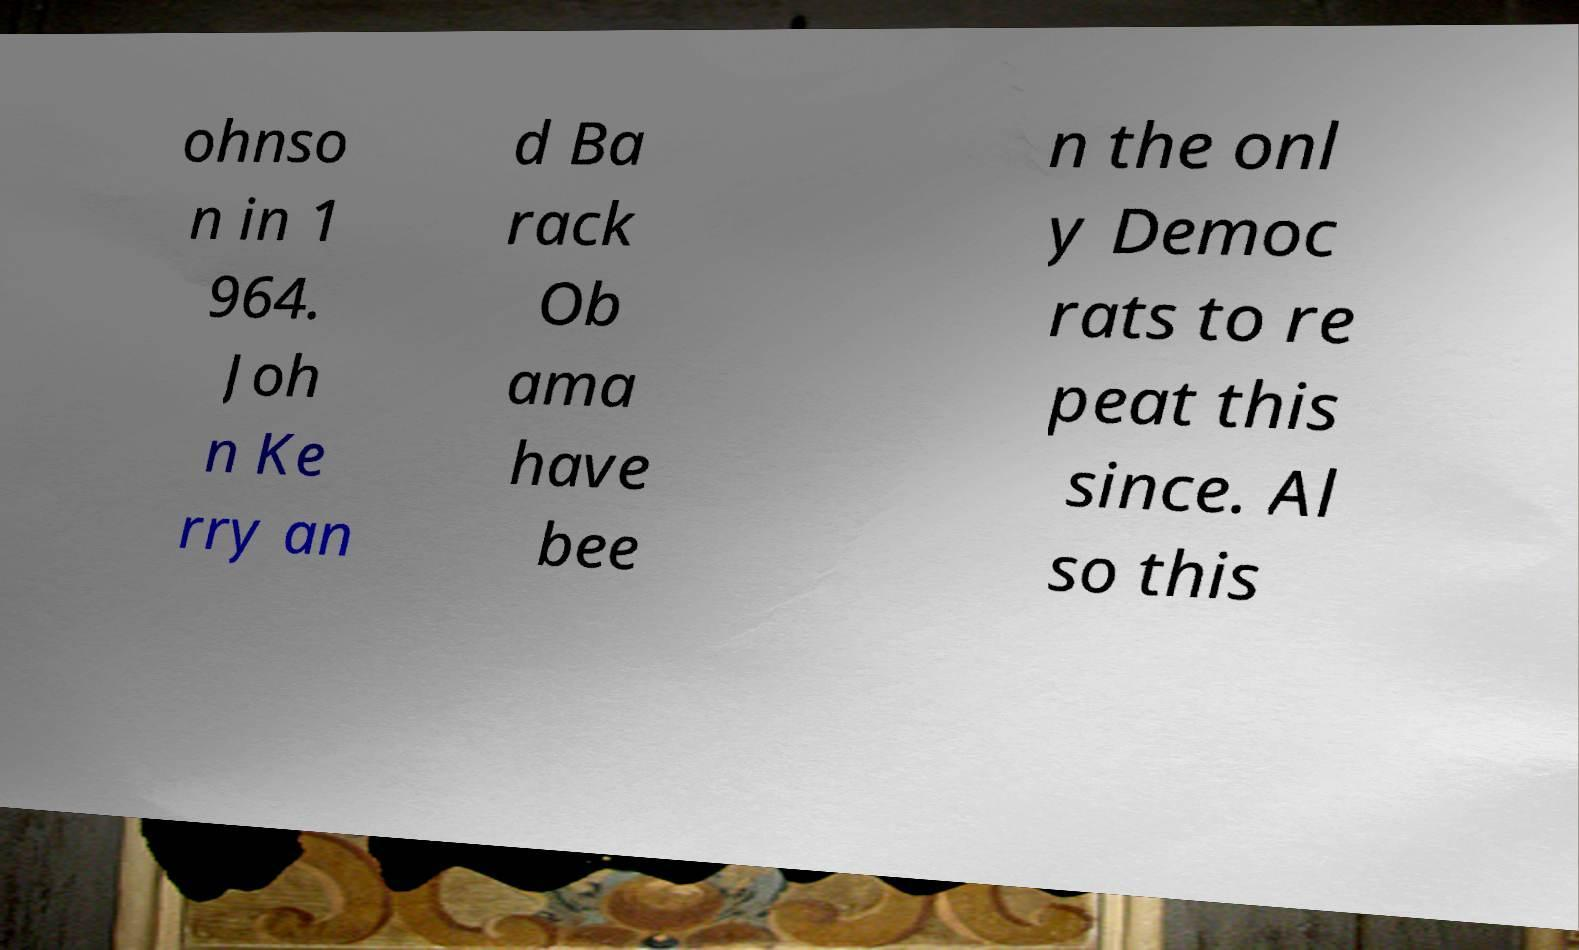Please identify and transcribe the text found in this image. ohnso n in 1 964. Joh n Ke rry an d Ba rack Ob ama have bee n the onl y Democ rats to re peat this since. Al so this 